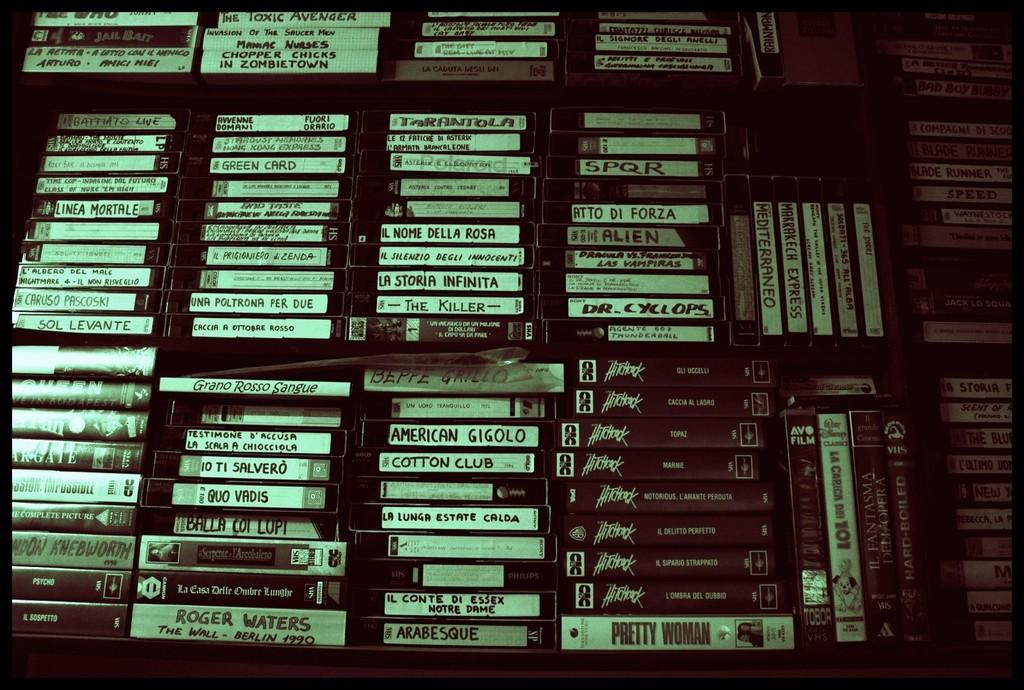<image>
Relay a brief, clear account of the picture shown. A VHS of American Gigolo sits in a big stack of videos on a shelf. 